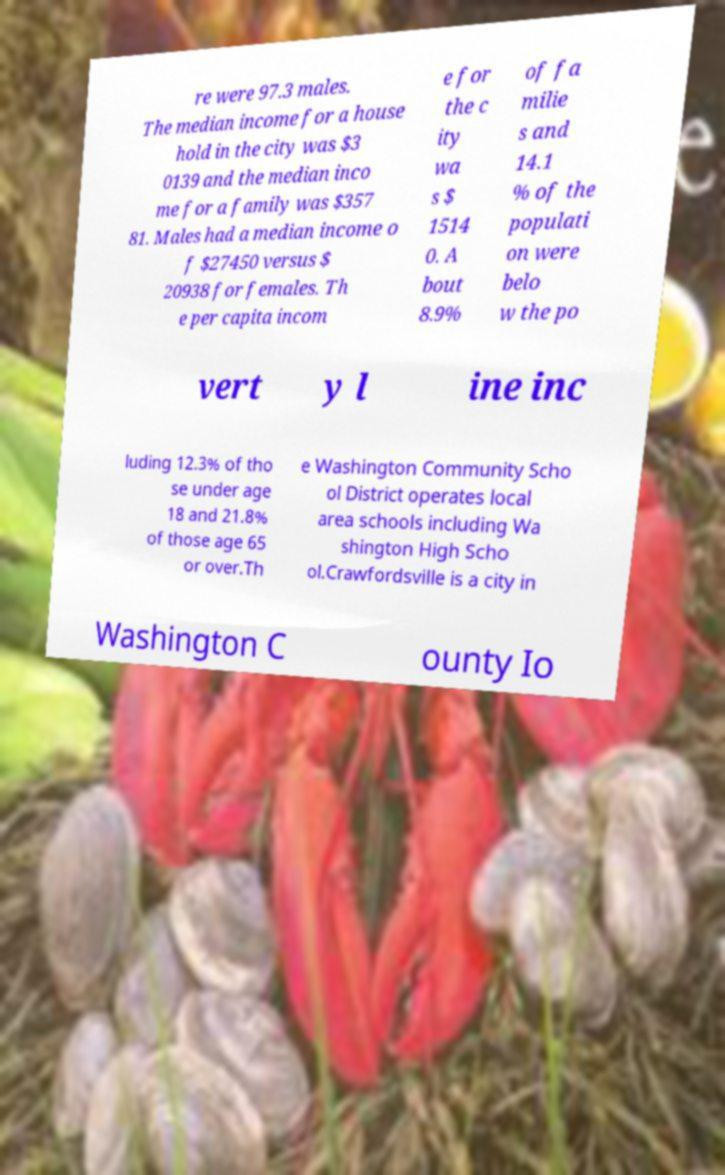I need the written content from this picture converted into text. Can you do that? re were 97.3 males. The median income for a house hold in the city was $3 0139 and the median inco me for a family was $357 81. Males had a median income o f $27450 versus $ 20938 for females. Th e per capita incom e for the c ity wa s $ 1514 0. A bout 8.9% of fa milie s and 14.1 % of the populati on were belo w the po vert y l ine inc luding 12.3% of tho se under age 18 and 21.8% of those age 65 or over.Th e Washington Community Scho ol District operates local area schools including Wa shington High Scho ol.Crawfordsville is a city in Washington C ounty Io 